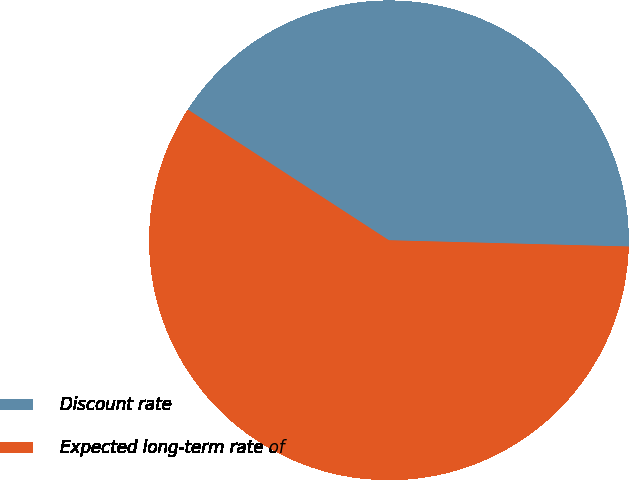Convert chart. <chart><loc_0><loc_0><loc_500><loc_500><pie_chart><fcel>Discount rate<fcel>Expected long-term rate of<nl><fcel>41.24%<fcel>58.76%<nl></chart> 